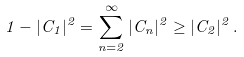Convert formula to latex. <formula><loc_0><loc_0><loc_500><loc_500>1 - | C _ { 1 } | ^ { 2 } = \sum _ { n = 2 } ^ { \infty } | C _ { n } | ^ { 2 } \geq | C _ { 2 } | ^ { 2 } \, .</formula> 